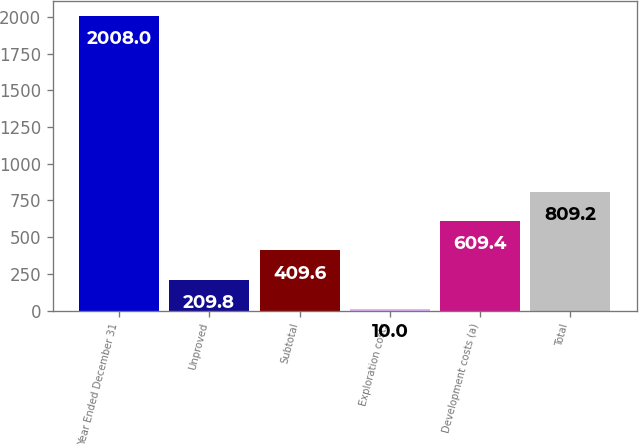<chart> <loc_0><loc_0><loc_500><loc_500><bar_chart><fcel>Year Ended December 31<fcel>Unproved<fcel>Subtotal<fcel>Exploration costs<fcel>Development costs (a)<fcel>Total<nl><fcel>2008<fcel>209.8<fcel>409.6<fcel>10<fcel>609.4<fcel>809.2<nl></chart> 